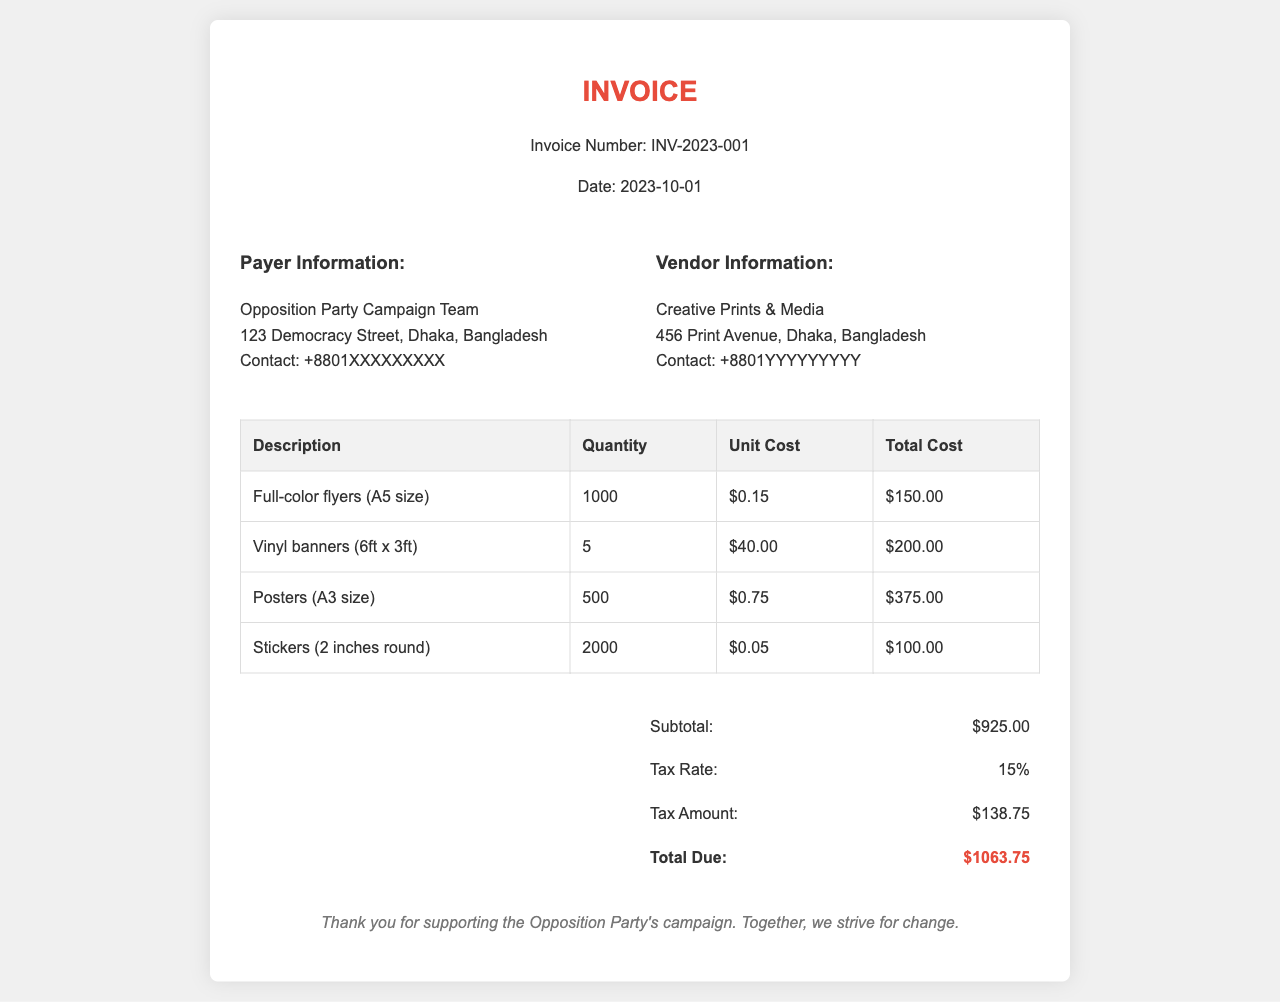What is the invoice number? The invoice number is specified at the top of the document as INV-2023-001.
Answer: INV-2023-001 What is the date of the invoice? The date is mentioned in the header section of the document as 2023-10-01.
Answer: 2023-10-01 Who is the vendor for the printing services? The vendor's name is listed in the vendor information section. It is Creative Prints & Media.
Answer: Creative Prints & Media What is the total cost for the vinyl banners? The total cost is calculated in the invoice table based on the quantity and unit cost, which is $200.00.
Answer: $200.00 What is the subtotal of all items purchased? The subtotal is summarized at the bottom of the invoice as $925.00.
Answer: $925.00 What is the tax rate applied to the invoice? The tax rate mentioned in the summary section of the document is 15%.
Answer: 15% How many full-color flyers were ordered? The quantity of full-color flyers ordered is indicated in the invoice table as 1000.
Answer: 1000 What is the total due for the invoice? The total due is stated at the end of the invoice summary as $1063.75.
Answer: $1063.75 What type of material was used for the stickers? The invoice specifies the stickers are 2 inches round in size, this describes the material type.
Answer: 2 inches round 